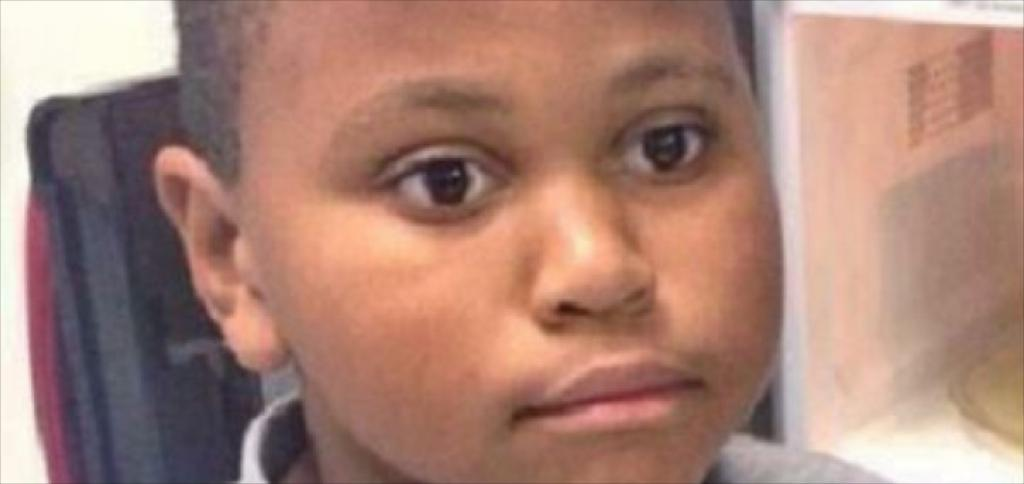Who is the main subject in the image? There is a boy in the image. What is the boy wearing? The boy is wearing a grey color shirt. What can be seen in the background of the image? There is a black color object in the background of the image. What type of chin can be seen on the boy in the image? There is no chin visible on the boy in the image; only his shirt and the background object are mentioned. 